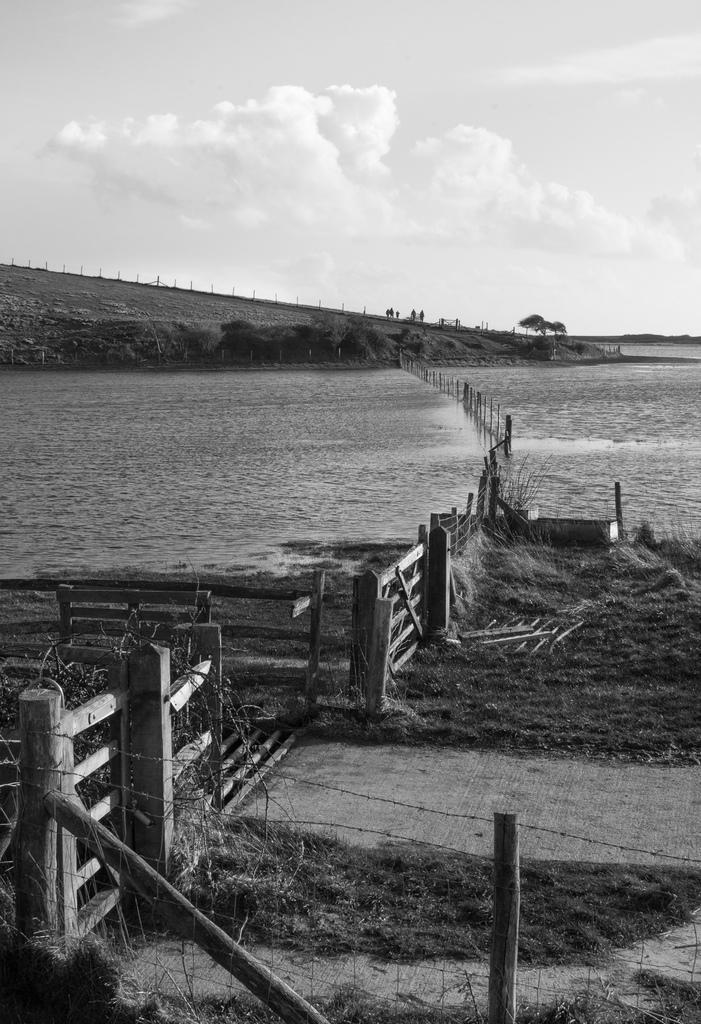Please provide a concise description of this image. In this image there is a fence on the land having grass. There is a fence in the water. Background there are trees on the land. Left side there is a hill. Top of the image there is sky, having clouds. 